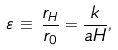Convert formula to latex. <formula><loc_0><loc_0><loc_500><loc_500>\varepsilon \, \equiv \, \frac { r _ { H } } { r _ { 0 } } = \frac { k } { a H } ,</formula> 